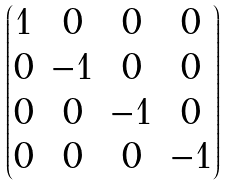<formula> <loc_0><loc_0><loc_500><loc_500>\begin{pmatrix} 1 & 0 & 0 & 0 \\ 0 & - 1 & 0 & 0 \\ 0 & 0 & - 1 & 0 \\ 0 & 0 & 0 & - 1 \end{pmatrix}</formula> 